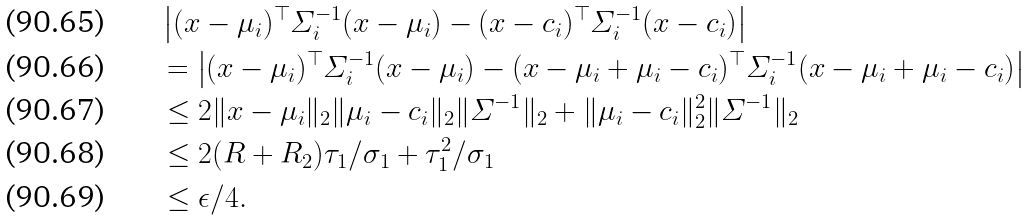<formula> <loc_0><loc_0><loc_500><loc_500>& \left | ( x - \mu _ { i } ) ^ { \top } \varSigma ^ { - 1 } _ { i } ( x - \mu _ { i } ) - ( x - c _ { i } ) ^ { \top } \varSigma ^ { - 1 } _ { i } ( x - c _ { i } ) \right | \\ & = \left | ( x - \mu _ { i } ) ^ { \top } \varSigma ^ { - 1 } _ { i } ( x - \mu _ { i } ) - ( x - \mu _ { i } + \mu _ { i } - c _ { i } ) ^ { \top } \varSigma ^ { - 1 } _ { i } ( x - \mu _ { i } + \mu _ { i } - c _ { i } ) \right | \\ & \leq 2 \| x - \mu _ { i } \| _ { 2 } \| \mu _ { i } - c _ { i } \| _ { 2 } \| \varSigma ^ { - 1 } \| _ { 2 } + \| \mu _ { i } - c _ { i } \| _ { 2 } ^ { 2 } \| \varSigma ^ { - 1 } \| _ { 2 } \\ & \leq 2 ( R + R _ { 2 } ) \tau _ { 1 } / \sigma _ { 1 } + \tau _ { 1 } ^ { 2 } / \sigma _ { 1 } \\ & \leq \epsilon / 4 .</formula> 